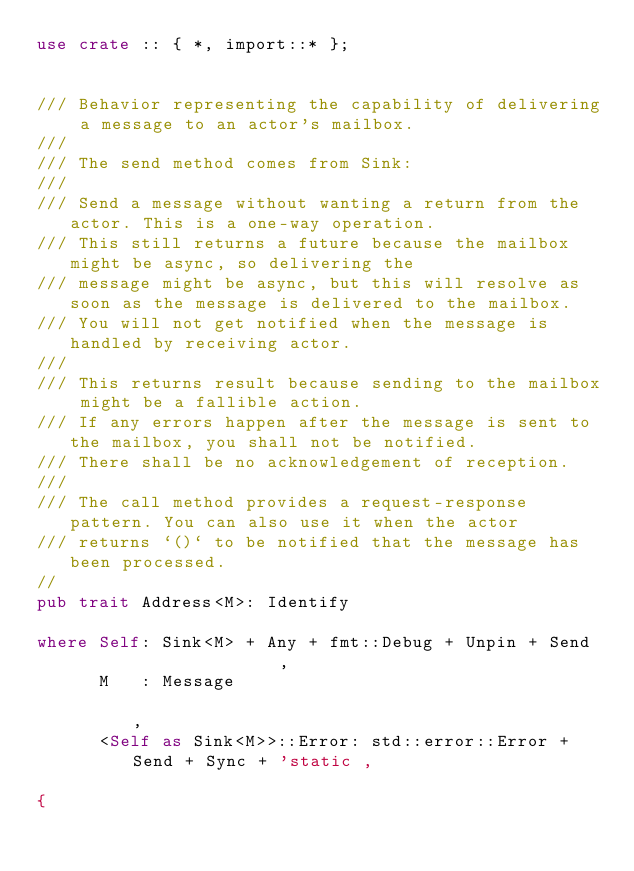Convert code to text. <code><loc_0><loc_0><loc_500><loc_500><_Rust_>use crate :: { *, import::* };


/// Behavior representing the capability of delivering a message to an actor's mailbox.
///
/// The send method comes from Sink:
///
/// Send a message without wanting a return from the actor. This is a one-way operation.
/// This still returns a future because the mailbox might be async, so delivering the
/// message might be async, but this will resolve as soon as the message is delivered to the mailbox.
/// You will not get notified when the message is handled by receiving actor.
///
/// This returns result because sending to the mailbox might be a fallible action.
/// If any errors happen after the message is sent to the mailbox, you shall not be notified.
/// There shall be no acknowledgement of reception.
///
/// The call method provides a request-response pattern. You can also use it when the actor
/// returns `()` to be notified that the message has been processed.
//
pub trait Address<M>: Identify

where Self: Sink<M> + Any + fmt::Debug + Unpin + Send                     ,
      M   : Message                                                       ,
      <Self as Sink<M>>::Error: std::error::Error + Send + Sync + 'static ,

{</code> 